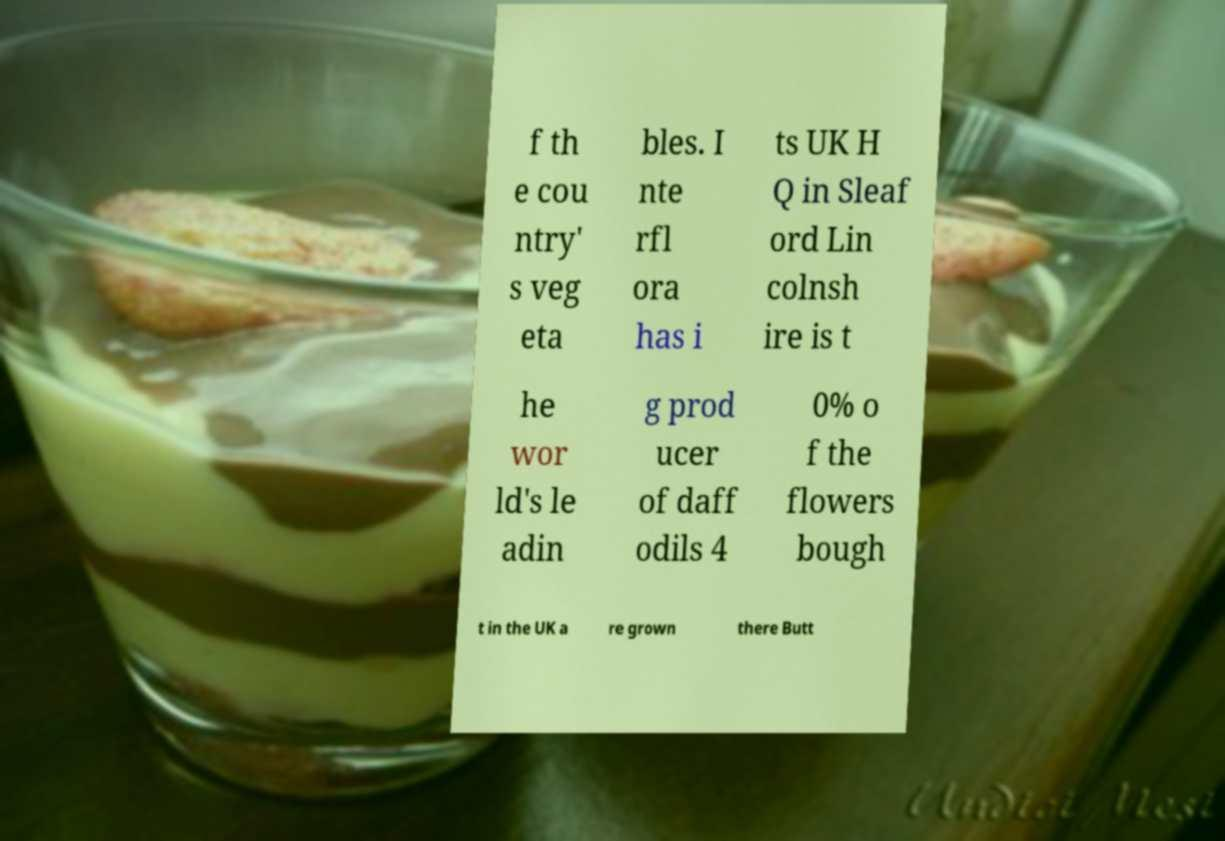I need the written content from this picture converted into text. Can you do that? f th e cou ntry' s veg eta bles. I nte rfl ora has i ts UK H Q in Sleaf ord Lin colnsh ire is t he wor ld's le adin g prod ucer of daff odils 4 0% o f the flowers bough t in the UK a re grown there Butt 